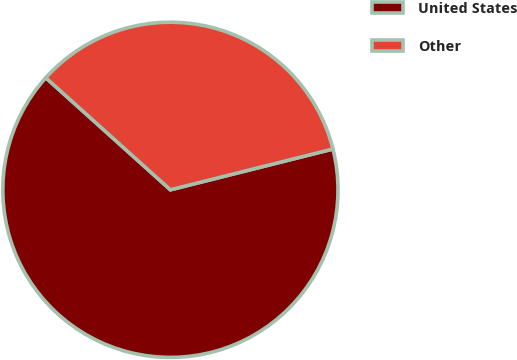Convert chart. <chart><loc_0><loc_0><loc_500><loc_500><pie_chart><fcel>United States<fcel>Other<nl><fcel>65.57%<fcel>34.43%<nl></chart> 